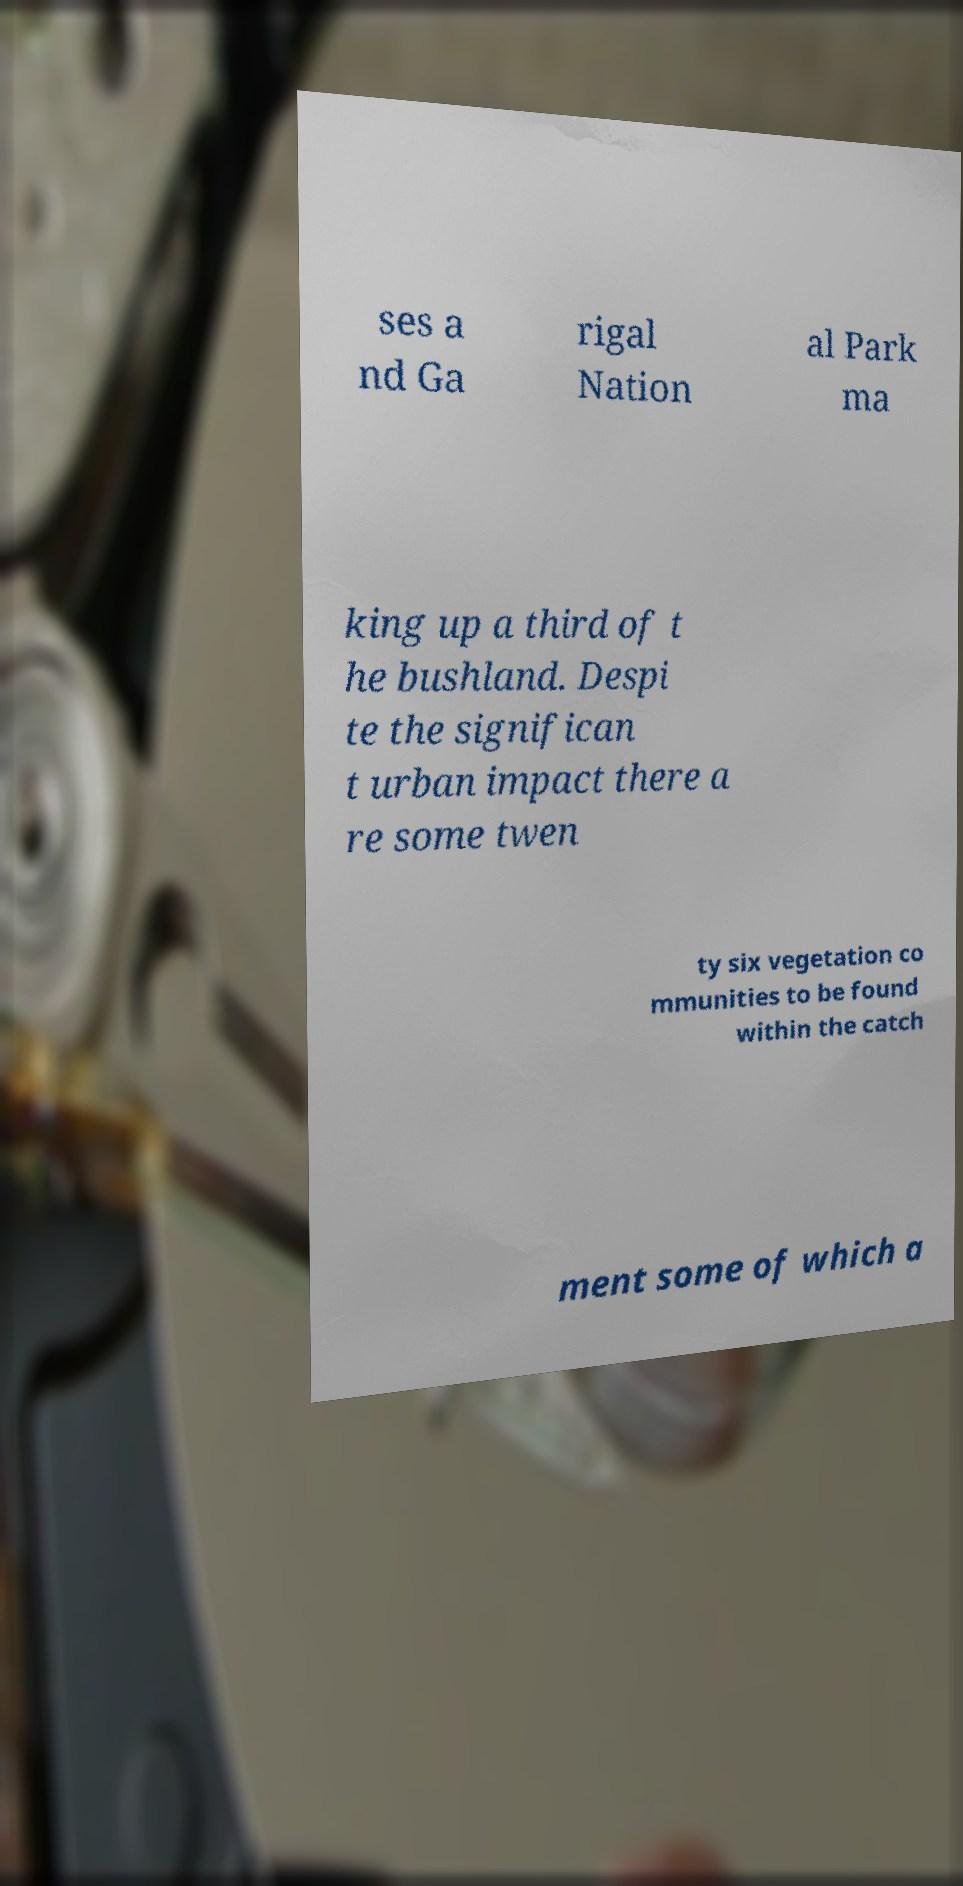For documentation purposes, I need the text within this image transcribed. Could you provide that? ses a nd Ga rigal Nation al Park ma king up a third of t he bushland. Despi te the significan t urban impact there a re some twen ty six vegetation co mmunities to be found within the catch ment some of which a 